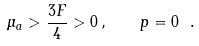<formula> <loc_0><loc_0><loc_500><loc_500>\mu _ { a } > { \frac { 3 F } { 4 } } > 0 \, , \quad p = 0 \ .</formula> 